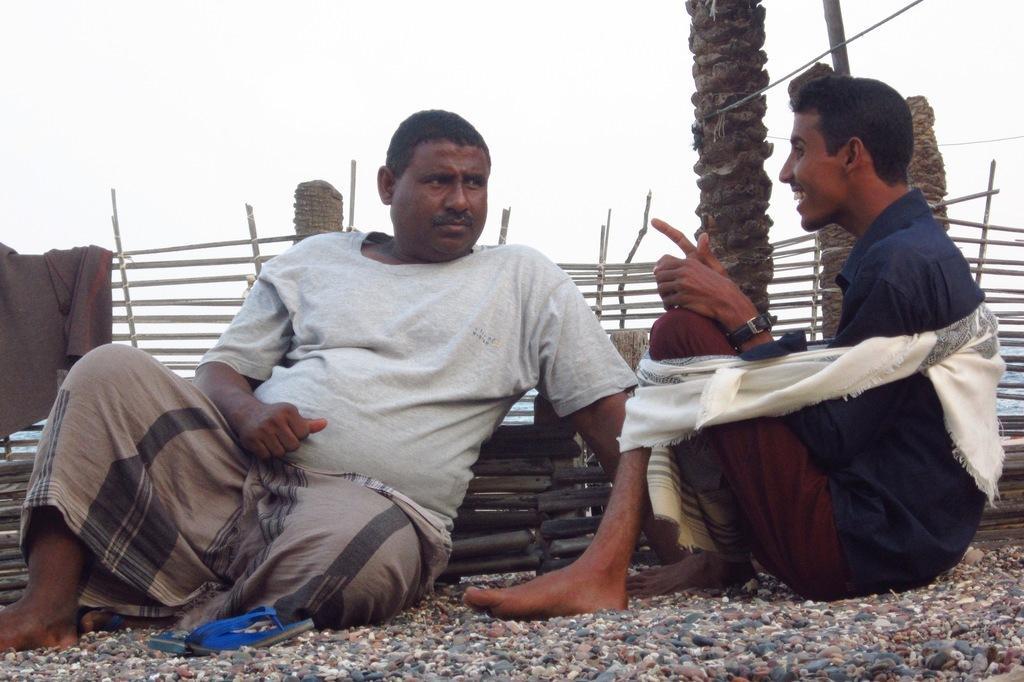Please provide a concise description of this image. There are two persons sitting in the center of the image. At the bottom of the image there are stones. 